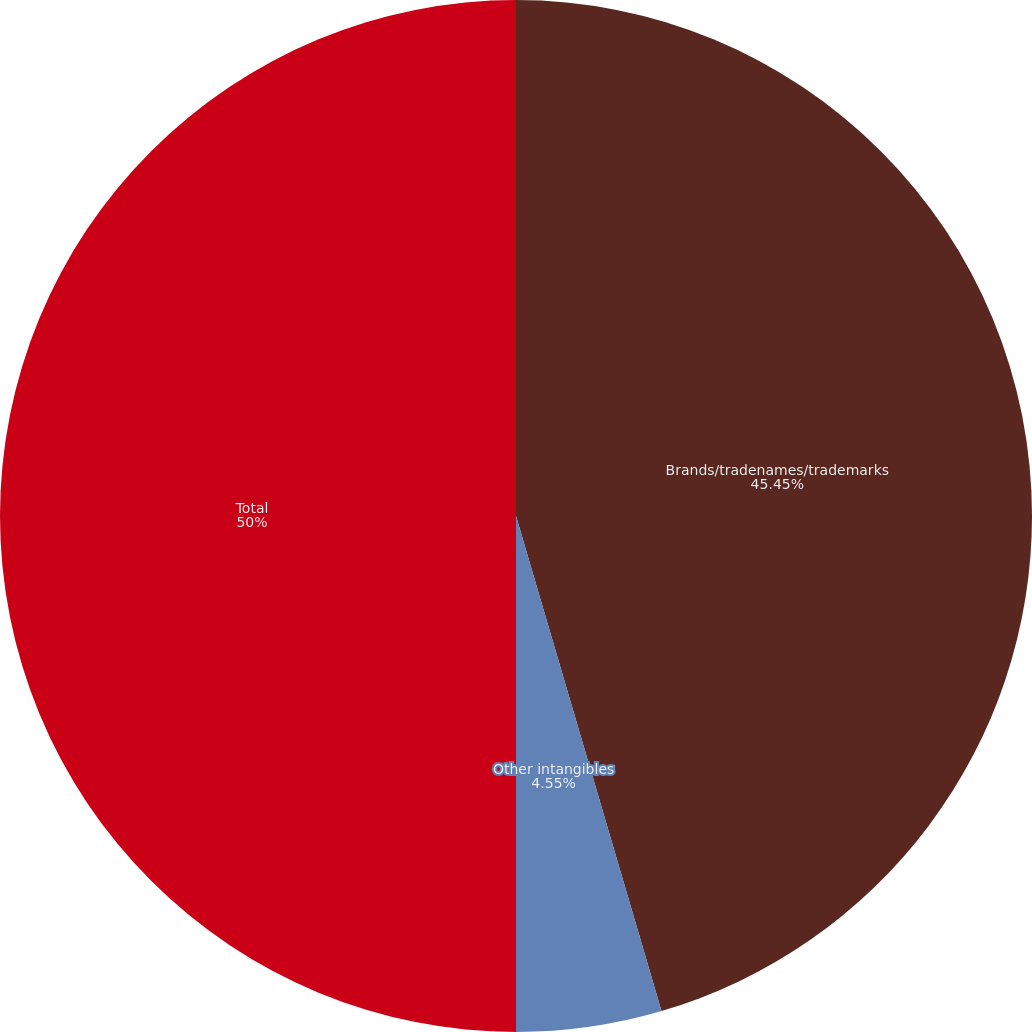<chart> <loc_0><loc_0><loc_500><loc_500><pie_chart><fcel>Brands/tradenames/trademarks<fcel>Other intangibles<fcel>Foreign currency translation<fcel>Total<nl><fcel>45.45%<fcel>4.55%<fcel>0.0%<fcel>50.0%<nl></chart> 